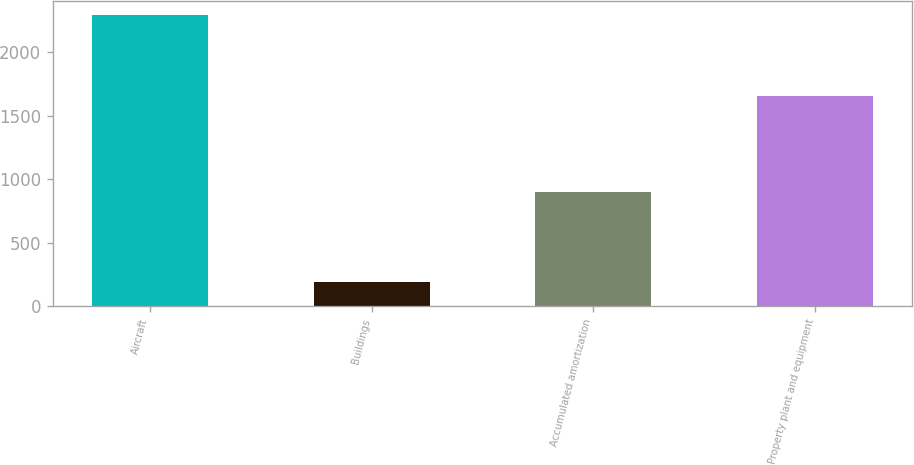Convert chart to OTSL. <chart><loc_0><loc_0><loc_500><loc_500><bar_chart><fcel>Aircraft<fcel>Buildings<fcel>Accumulated amortization<fcel>Property plant and equipment<nl><fcel>2291<fcel>190<fcel>896<fcel>1653<nl></chart> 